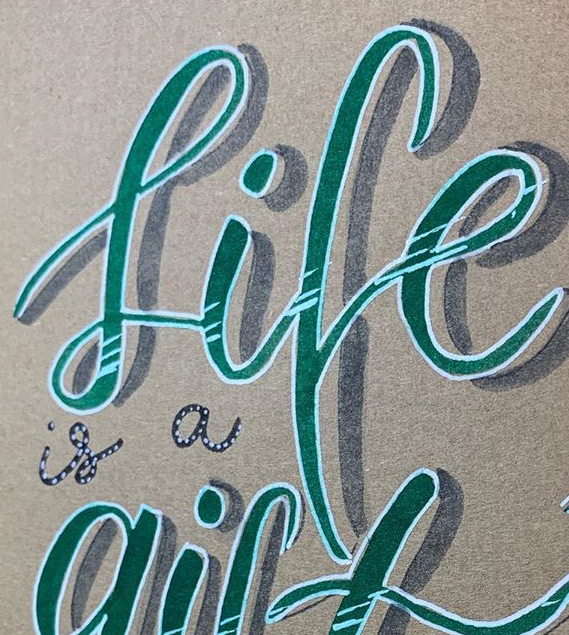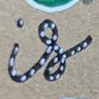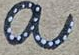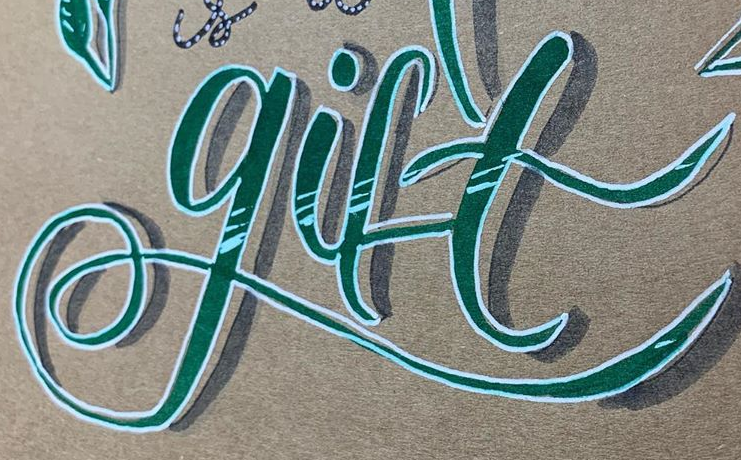What text is displayed in these images sequentially, separated by a semicolon? life; is; a; gift 